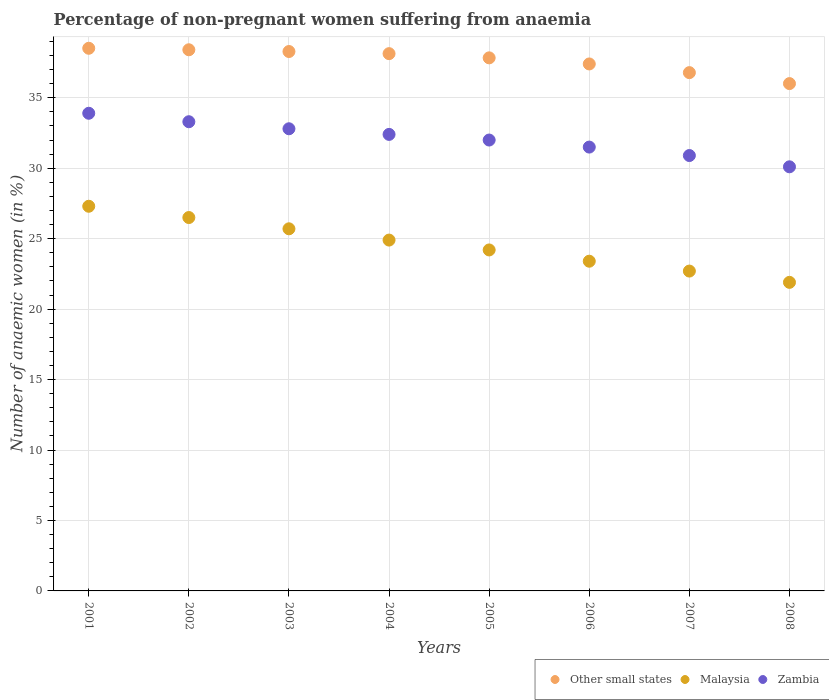What is the percentage of non-pregnant women suffering from anaemia in Other small states in 2005?
Offer a terse response. 37.83. Across all years, what is the maximum percentage of non-pregnant women suffering from anaemia in Other small states?
Ensure brevity in your answer.  38.51. Across all years, what is the minimum percentage of non-pregnant women suffering from anaemia in Zambia?
Offer a terse response. 30.1. In which year was the percentage of non-pregnant women suffering from anaemia in Other small states maximum?
Ensure brevity in your answer.  2001. What is the total percentage of non-pregnant women suffering from anaemia in Malaysia in the graph?
Ensure brevity in your answer.  196.6. What is the difference between the percentage of non-pregnant women suffering from anaemia in Malaysia in 2003 and that in 2005?
Offer a terse response. 1.5. What is the difference between the percentage of non-pregnant women suffering from anaemia in Malaysia in 2004 and the percentage of non-pregnant women suffering from anaemia in Zambia in 2002?
Your answer should be very brief. -8.4. What is the average percentage of non-pregnant women suffering from anaemia in Other small states per year?
Provide a succinct answer. 37.67. In the year 2003, what is the difference between the percentage of non-pregnant women suffering from anaemia in Other small states and percentage of non-pregnant women suffering from anaemia in Zambia?
Your answer should be compact. 5.48. In how many years, is the percentage of non-pregnant women suffering from anaemia in Other small states greater than 21 %?
Provide a succinct answer. 8. What is the ratio of the percentage of non-pregnant women suffering from anaemia in Zambia in 2003 to that in 2006?
Your answer should be very brief. 1.04. Is the percentage of non-pregnant women suffering from anaemia in Other small states in 2001 less than that in 2005?
Keep it short and to the point. No. Is the difference between the percentage of non-pregnant women suffering from anaemia in Other small states in 2007 and 2008 greater than the difference between the percentage of non-pregnant women suffering from anaemia in Zambia in 2007 and 2008?
Keep it short and to the point. No. What is the difference between the highest and the second highest percentage of non-pregnant women suffering from anaemia in Other small states?
Offer a terse response. 0.11. What is the difference between the highest and the lowest percentage of non-pregnant women suffering from anaemia in Zambia?
Provide a succinct answer. 3.8. Is the percentage of non-pregnant women suffering from anaemia in Other small states strictly less than the percentage of non-pregnant women suffering from anaemia in Zambia over the years?
Make the answer very short. No. How many legend labels are there?
Make the answer very short. 3. What is the title of the graph?
Keep it short and to the point. Percentage of non-pregnant women suffering from anaemia. Does "Korea (Republic)" appear as one of the legend labels in the graph?
Keep it short and to the point. No. What is the label or title of the Y-axis?
Offer a very short reply. Number of anaemic women (in %). What is the Number of anaemic women (in %) of Other small states in 2001?
Offer a terse response. 38.51. What is the Number of anaemic women (in %) of Malaysia in 2001?
Give a very brief answer. 27.3. What is the Number of anaemic women (in %) in Zambia in 2001?
Ensure brevity in your answer.  33.9. What is the Number of anaemic women (in %) of Other small states in 2002?
Provide a succinct answer. 38.41. What is the Number of anaemic women (in %) of Zambia in 2002?
Your response must be concise. 33.3. What is the Number of anaemic women (in %) of Other small states in 2003?
Offer a terse response. 38.28. What is the Number of anaemic women (in %) of Malaysia in 2003?
Keep it short and to the point. 25.7. What is the Number of anaemic women (in %) in Zambia in 2003?
Your response must be concise. 32.8. What is the Number of anaemic women (in %) of Other small states in 2004?
Your answer should be compact. 38.13. What is the Number of anaemic women (in %) of Malaysia in 2004?
Give a very brief answer. 24.9. What is the Number of anaemic women (in %) of Zambia in 2004?
Provide a short and direct response. 32.4. What is the Number of anaemic women (in %) in Other small states in 2005?
Keep it short and to the point. 37.83. What is the Number of anaemic women (in %) in Malaysia in 2005?
Your response must be concise. 24.2. What is the Number of anaemic women (in %) in Zambia in 2005?
Offer a terse response. 32. What is the Number of anaemic women (in %) of Other small states in 2006?
Your answer should be compact. 37.4. What is the Number of anaemic women (in %) of Malaysia in 2006?
Make the answer very short. 23.4. What is the Number of anaemic women (in %) in Zambia in 2006?
Provide a short and direct response. 31.5. What is the Number of anaemic women (in %) in Other small states in 2007?
Make the answer very short. 36.78. What is the Number of anaemic women (in %) in Malaysia in 2007?
Provide a short and direct response. 22.7. What is the Number of anaemic women (in %) in Zambia in 2007?
Provide a succinct answer. 30.9. What is the Number of anaemic women (in %) of Other small states in 2008?
Make the answer very short. 36.01. What is the Number of anaemic women (in %) of Malaysia in 2008?
Offer a terse response. 21.9. What is the Number of anaemic women (in %) in Zambia in 2008?
Make the answer very short. 30.1. Across all years, what is the maximum Number of anaemic women (in %) in Other small states?
Offer a terse response. 38.51. Across all years, what is the maximum Number of anaemic women (in %) of Malaysia?
Offer a very short reply. 27.3. Across all years, what is the maximum Number of anaemic women (in %) of Zambia?
Your response must be concise. 33.9. Across all years, what is the minimum Number of anaemic women (in %) in Other small states?
Your response must be concise. 36.01. Across all years, what is the minimum Number of anaemic women (in %) in Malaysia?
Offer a very short reply. 21.9. Across all years, what is the minimum Number of anaemic women (in %) of Zambia?
Provide a short and direct response. 30.1. What is the total Number of anaemic women (in %) in Other small states in the graph?
Make the answer very short. 301.36. What is the total Number of anaemic women (in %) in Malaysia in the graph?
Keep it short and to the point. 196.6. What is the total Number of anaemic women (in %) in Zambia in the graph?
Ensure brevity in your answer.  256.9. What is the difference between the Number of anaemic women (in %) in Other small states in 2001 and that in 2002?
Make the answer very short. 0.11. What is the difference between the Number of anaemic women (in %) in Other small states in 2001 and that in 2003?
Your answer should be very brief. 0.23. What is the difference between the Number of anaemic women (in %) of Malaysia in 2001 and that in 2003?
Your response must be concise. 1.6. What is the difference between the Number of anaemic women (in %) in Other small states in 2001 and that in 2004?
Provide a succinct answer. 0.38. What is the difference between the Number of anaemic women (in %) in Malaysia in 2001 and that in 2004?
Provide a short and direct response. 2.4. What is the difference between the Number of anaemic women (in %) in Zambia in 2001 and that in 2004?
Keep it short and to the point. 1.5. What is the difference between the Number of anaemic women (in %) of Other small states in 2001 and that in 2005?
Offer a terse response. 0.68. What is the difference between the Number of anaemic women (in %) of Malaysia in 2001 and that in 2005?
Offer a very short reply. 3.1. What is the difference between the Number of anaemic women (in %) in Other small states in 2001 and that in 2006?
Ensure brevity in your answer.  1.11. What is the difference between the Number of anaemic women (in %) of Zambia in 2001 and that in 2006?
Provide a succinct answer. 2.4. What is the difference between the Number of anaemic women (in %) of Other small states in 2001 and that in 2007?
Offer a terse response. 1.73. What is the difference between the Number of anaemic women (in %) of Malaysia in 2001 and that in 2007?
Offer a terse response. 4.6. What is the difference between the Number of anaemic women (in %) of Zambia in 2001 and that in 2007?
Your answer should be very brief. 3. What is the difference between the Number of anaemic women (in %) of Other small states in 2001 and that in 2008?
Make the answer very short. 2.51. What is the difference between the Number of anaemic women (in %) in Malaysia in 2001 and that in 2008?
Make the answer very short. 5.4. What is the difference between the Number of anaemic women (in %) in Zambia in 2001 and that in 2008?
Offer a terse response. 3.8. What is the difference between the Number of anaemic women (in %) in Other small states in 2002 and that in 2003?
Make the answer very short. 0.12. What is the difference between the Number of anaemic women (in %) of Other small states in 2002 and that in 2004?
Your answer should be very brief. 0.28. What is the difference between the Number of anaemic women (in %) of Malaysia in 2002 and that in 2004?
Give a very brief answer. 1.6. What is the difference between the Number of anaemic women (in %) in Other small states in 2002 and that in 2005?
Provide a short and direct response. 0.57. What is the difference between the Number of anaemic women (in %) in Zambia in 2002 and that in 2005?
Give a very brief answer. 1.3. What is the difference between the Number of anaemic women (in %) in Other small states in 2002 and that in 2006?
Provide a succinct answer. 1.01. What is the difference between the Number of anaemic women (in %) in Zambia in 2002 and that in 2006?
Offer a very short reply. 1.8. What is the difference between the Number of anaemic women (in %) of Other small states in 2002 and that in 2007?
Provide a short and direct response. 1.62. What is the difference between the Number of anaemic women (in %) of Zambia in 2002 and that in 2007?
Provide a short and direct response. 2.4. What is the difference between the Number of anaemic women (in %) of Other small states in 2002 and that in 2008?
Offer a terse response. 2.4. What is the difference between the Number of anaemic women (in %) of Malaysia in 2002 and that in 2008?
Offer a terse response. 4.6. What is the difference between the Number of anaemic women (in %) of Other small states in 2003 and that in 2004?
Make the answer very short. 0.15. What is the difference between the Number of anaemic women (in %) of Malaysia in 2003 and that in 2004?
Your response must be concise. 0.8. What is the difference between the Number of anaemic women (in %) of Other small states in 2003 and that in 2005?
Your response must be concise. 0.45. What is the difference between the Number of anaemic women (in %) of Zambia in 2003 and that in 2005?
Your answer should be compact. 0.8. What is the difference between the Number of anaemic women (in %) in Other small states in 2003 and that in 2006?
Keep it short and to the point. 0.88. What is the difference between the Number of anaemic women (in %) in Zambia in 2003 and that in 2006?
Make the answer very short. 1.3. What is the difference between the Number of anaemic women (in %) of Other small states in 2003 and that in 2007?
Your answer should be very brief. 1.5. What is the difference between the Number of anaemic women (in %) of Malaysia in 2003 and that in 2007?
Give a very brief answer. 3. What is the difference between the Number of anaemic women (in %) of Other small states in 2003 and that in 2008?
Give a very brief answer. 2.28. What is the difference between the Number of anaemic women (in %) in Zambia in 2003 and that in 2008?
Provide a short and direct response. 2.7. What is the difference between the Number of anaemic women (in %) in Other small states in 2004 and that in 2005?
Give a very brief answer. 0.3. What is the difference between the Number of anaemic women (in %) in Zambia in 2004 and that in 2005?
Ensure brevity in your answer.  0.4. What is the difference between the Number of anaemic women (in %) of Other small states in 2004 and that in 2006?
Your response must be concise. 0.73. What is the difference between the Number of anaemic women (in %) of Malaysia in 2004 and that in 2006?
Offer a terse response. 1.5. What is the difference between the Number of anaemic women (in %) of Other small states in 2004 and that in 2007?
Your response must be concise. 1.35. What is the difference between the Number of anaemic women (in %) in Malaysia in 2004 and that in 2007?
Provide a succinct answer. 2.2. What is the difference between the Number of anaemic women (in %) in Zambia in 2004 and that in 2007?
Your answer should be very brief. 1.5. What is the difference between the Number of anaemic women (in %) in Other small states in 2004 and that in 2008?
Provide a succinct answer. 2.13. What is the difference between the Number of anaemic women (in %) of Malaysia in 2004 and that in 2008?
Give a very brief answer. 3. What is the difference between the Number of anaemic women (in %) in Zambia in 2004 and that in 2008?
Your response must be concise. 2.3. What is the difference between the Number of anaemic women (in %) of Other small states in 2005 and that in 2006?
Make the answer very short. 0.43. What is the difference between the Number of anaemic women (in %) in Malaysia in 2005 and that in 2006?
Offer a very short reply. 0.8. What is the difference between the Number of anaemic women (in %) of Other small states in 2005 and that in 2007?
Provide a succinct answer. 1.05. What is the difference between the Number of anaemic women (in %) in Zambia in 2005 and that in 2007?
Ensure brevity in your answer.  1.1. What is the difference between the Number of anaemic women (in %) of Other small states in 2005 and that in 2008?
Offer a very short reply. 1.83. What is the difference between the Number of anaemic women (in %) in Other small states in 2006 and that in 2007?
Offer a terse response. 0.62. What is the difference between the Number of anaemic women (in %) of Malaysia in 2006 and that in 2007?
Make the answer very short. 0.7. What is the difference between the Number of anaemic women (in %) of Other small states in 2006 and that in 2008?
Keep it short and to the point. 1.39. What is the difference between the Number of anaemic women (in %) in Other small states in 2007 and that in 2008?
Provide a short and direct response. 0.78. What is the difference between the Number of anaemic women (in %) of Other small states in 2001 and the Number of anaemic women (in %) of Malaysia in 2002?
Your answer should be compact. 12.01. What is the difference between the Number of anaemic women (in %) of Other small states in 2001 and the Number of anaemic women (in %) of Zambia in 2002?
Make the answer very short. 5.21. What is the difference between the Number of anaemic women (in %) of Malaysia in 2001 and the Number of anaemic women (in %) of Zambia in 2002?
Provide a succinct answer. -6. What is the difference between the Number of anaemic women (in %) of Other small states in 2001 and the Number of anaemic women (in %) of Malaysia in 2003?
Give a very brief answer. 12.81. What is the difference between the Number of anaemic women (in %) of Other small states in 2001 and the Number of anaemic women (in %) of Zambia in 2003?
Your answer should be compact. 5.71. What is the difference between the Number of anaemic women (in %) of Malaysia in 2001 and the Number of anaemic women (in %) of Zambia in 2003?
Your answer should be compact. -5.5. What is the difference between the Number of anaemic women (in %) in Other small states in 2001 and the Number of anaemic women (in %) in Malaysia in 2004?
Make the answer very short. 13.61. What is the difference between the Number of anaemic women (in %) of Other small states in 2001 and the Number of anaemic women (in %) of Zambia in 2004?
Your response must be concise. 6.11. What is the difference between the Number of anaemic women (in %) in Malaysia in 2001 and the Number of anaemic women (in %) in Zambia in 2004?
Provide a short and direct response. -5.1. What is the difference between the Number of anaemic women (in %) in Other small states in 2001 and the Number of anaemic women (in %) in Malaysia in 2005?
Offer a terse response. 14.31. What is the difference between the Number of anaemic women (in %) in Other small states in 2001 and the Number of anaemic women (in %) in Zambia in 2005?
Provide a short and direct response. 6.51. What is the difference between the Number of anaemic women (in %) of Malaysia in 2001 and the Number of anaemic women (in %) of Zambia in 2005?
Make the answer very short. -4.7. What is the difference between the Number of anaemic women (in %) in Other small states in 2001 and the Number of anaemic women (in %) in Malaysia in 2006?
Provide a short and direct response. 15.11. What is the difference between the Number of anaemic women (in %) of Other small states in 2001 and the Number of anaemic women (in %) of Zambia in 2006?
Make the answer very short. 7.01. What is the difference between the Number of anaemic women (in %) of Other small states in 2001 and the Number of anaemic women (in %) of Malaysia in 2007?
Make the answer very short. 15.81. What is the difference between the Number of anaemic women (in %) of Other small states in 2001 and the Number of anaemic women (in %) of Zambia in 2007?
Make the answer very short. 7.61. What is the difference between the Number of anaemic women (in %) in Other small states in 2001 and the Number of anaemic women (in %) in Malaysia in 2008?
Your answer should be compact. 16.61. What is the difference between the Number of anaemic women (in %) in Other small states in 2001 and the Number of anaemic women (in %) in Zambia in 2008?
Provide a succinct answer. 8.41. What is the difference between the Number of anaemic women (in %) of Other small states in 2002 and the Number of anaemic women (in %) of Malaysia in 2003?
Give a very brief answer. 12.71. What is the difference between the Number of anaemic women (in %) in Other small states in 2002 and the Number of anaemic women (in %) in Zambia in 2003?
Your answer should be compact. 5.61. What is the difference between the Number of anaemic women (in %) in Other small states in 2002 and the Number of anaemic women (in %) in Malaysia in 2004?
Keep it short and to the point. 13.51. What is the difference between the Number of anaemic women (in %) in Other small states in 2002 and the Number of anaemic women (in %) in Zambia in 2004?
Ensure brevity in your answer.  6.01. What is the difference between the Number of anaemic women (in %) in Malaysia in 2002 and the Number of anaemic women (in %) in Zambia in 2004?
Make the answer very short. -5.9. What is the difference between the Number of anaemic women (in %) of Other small states in 2002 and the Number of anaemic women (in %) of Malaysia in 2005?
Your response must be concise. 14.21. What is the difference between the Number of anaemic women (in %) in Other small states in 2002 and the Number of anaemic women (in %) in Zambia in 2005?
Keep it short and to the point. 6.41. What is the difference between the Number of anaemic women (in %) in Other small states in 2002 and the Number of anaemic women (in %) in Malaysia in 2006?
Give a very brief answer. 15.01. What is the difference between the Number of anaemic women (in %) of Other small states in 2002 and the Number of anaemic women (in %) of Zambia in 2006?
Offer a terse response. 6.91. What is the difference between the Number of anaemic women (in %) in Malaysia in 2002 and the Number of anaemic women (in %) in Zambia in 2006?
Ensure brevity in your answer.  -5. What is the difference between the Number of anaemic women (in %) of Other small states in 2002 and the Number of anaemic women (in %) of Malaysia in 2007?
Provide a succinct answer. 15.71. What is the difference between the Number of anaemic women (in %) of Other small states in 2002 and the Number of anaemic women (in %) of Zambia in 2007?
Your response must be concise. 7.51. What is the difference between the Number of anaemic women (in %) in Other small states in 2002 and the Number of anaemic women (in %) in Malaysia in 2008?
Provide a short and direct response. 16.51. What is the difference between the Number of anaemic women (in %) of Other small states in 2002 and the Number of anaemic women (in %) of Zambia in 2008?
Your answer should be very brief. 8.31. What is the difference between the Number of anaemic women (in %) of Malaysia in 2002 and the Number of anaemic women (in %) of Zambia in 2008?
Ensure brevity in your answer.  -3.6. What is the difference between the Number of anaemic women (in %) in Other small states in 2003 and the Number of anaemic women (in %) in Malaysia in 2004?
Your answer should be very brief. 13.38. What is the difference between the Number of anaemic women (in %) of Other small states in 2003 and the Number of anaemic women (in %) of Zambia in 2004?
Your response must be concise. 5.88. What is the difference between the Number of anaemic women (in %) in Other small states in 2003 and the Number of anaemic women (in %) in Malaysia in 2005?
Your answer should be compact. 14.08. What is the difference between the Number of anaemic women (in %) of Other small states in 2003 and the Number of anaemic women (in %) of Zambia in 2005?
Provide a short and direct response. 6.28. What is the difference between the Number of anaemic women (in %) in Malaysia in 2003 and the Number of anaemic women (in %) in Zambia in 2005?
Provide a short and direct response. -6.3. What is the difference between the Number of anaemic women (in %) in Other small states in 2003 and the Number of anaemic women (in %) in Malaysia in 2006?
Ensure brevity in your answer.  14.88. What is the difference between the Number of anaemic women (in %) in Other small states in 2003 and the Number of anaemic women (in %) in Zambia in 2006?
Ensure brevity in your answer.  6.78. What is the difference between the Number of anaemic women (in %) in Other small states in 2003 and the Number of anaemic women (in %) in Malaysia in 2007?
Provide a short and direct response. 15.58. What is the difference between the Number of anaemic women (in %) of Other small states in 2003 and the Number of anaemic women (in %) of Zambia in 2007?
Ensure brevity in your answer.  7.38. What is the difference between the Number of anaemic women (in %) in Malaysia in 2003 and the Number of anaemic women (in %) in Zambia in 2007?
Keep it short and to the point. -5.2. What is the difference between the Number of anaemic women (in %) in Other small states in 2003 and the Number of anaemic women (in %) in Malaysia in 2008?
Your response must be concise. 16.38. What is the difference between the Number of anaemic women (in %) of Other small states in 2003 and the Number of anaemic women (in %) of Zambia in 2008?
Give a very brief answer. 8.18. What is the difference between the Number of anaemic women (in %) in Malaysia in 2003 and the Number of anaemic women (in %) in Zambia in 2008?
Make the answer very short. -4.4. What is the difference between the Number of anaemic women (in %) of Other small states in 2004 and the Number of anaemic women (in %) of Malaysia in 2005?
Your answer should be compact. 13.93. What is the difference between the Number of anaemic women (in %) of Other small states in 2004 and the Number of anaemic women (in %) of Zambia in 2005?
Provide a succinct answer. 6.13. What is the difference between the Number of anaemic women (in %) in Malaysia in 2004 and the Number of anaemic women (in %) in Zambia in 2005?
Offer a terse response. -7.1. What is the difference between the Number of anaemic women (in %) in Other small states in 2004 and the Number of anaemic women (in %) in Malaysia in 2006?
Offer a very short reply. 14.73. What is the difference between the Number of anaemic women (in %) of Other small states in 2004 and the Number of anaemic women (in %) of Zambia in 2006?
Your response must be concise. 6.63. What is the difference between the Number of anaemic women (in %) in Malaysia in 2004 and the Number of anaemic women (in %) in Zambia in 2006?
Make the answer very short. -6.6. What is the difference between the Number of anaemic women (in %) of Other small states in 2004 and the Number of anaemic women (in %) of Malaysia in 2007?
Your response must be concise. 15.43. What is the difference between the Number of anaemic women (in %) in Other small states in 2004 and the Number of anaemic women (in %) in Zambia in 2007?
Your answer should be very brief. 7.23. What is the difference between the Number of anaemic women (in %) in Other small states in 2004 and the Number of anaemic women (in %) in Malaysia in 2008?
Keep it short and to the point. 16.23. What is the difference between the Number of anaemic women (in %) of Other small states in 2004 and the Number of anaemic women (in %) of Zambia in 2008?
Keep it short and to the point. 8.03. What is the difference between the Number of anaemic women (in %) in Other small states in 2005 and the Number of anaemic women (in %) in Malaysia in 2006?
Your answer should be compact. 14.43. What is the difference between the Number of anaemic women (in %) of Other small states in 2005 and the Number of anaemic women (in %) of Zambia in 2006?
Give a very brief answer. 6.33. What is the difference between the Number of anaemic women (in %) in Malaysia in 2005 and the Number of anaemic women (in %) in Zambia in 2006?
Ensure brevity in your answer.  -7.3. What is the difference between the Number of anaemic women (in %) of Other small states in 2005 and the Number of anaemic women (in %) of Malaysia in 2007?
Provide a succinct answer. 15.13. What is the difference between the Number of anaemic women (in %) of Other small states in 2005 and the Number of anaemic women (in %) of Zambia in 2007?
Ensure brevity in your answer.  6.93. What is the difference between the Number of anaemic women (in %) of Other small states in 2005 and the Number of anaemic women (in %) of Malaysia in 2008?
Provide a succinct answer. 15.93. What is the difference between the Number of anaemic women (in %) in Other small states in 2005 and the Number of anaemic women (in %) in Zambia in 2008?
Offer a terse response. 7.73. What is the difference between the Number of anaemic women (in %) of Malaysia in 2005 and the Number of anaemic women (in %) of Zambia in 2008?
Make the answer very short. -5.9. What is the difference between the Number of anaemic women (in %) in Other small states in 2006 and the Number of anaemic women (in %) in Malaysia in 2007?
Offer a terse response. 14.7. What is the difference between the Number of anaemic women (in %) in Other small states in 2006 and the Number of anaemic women (in %) in Zambia in 2007?
Provide a short and direct response. 6.5. What is the difference between the Number of anaemic women (in %) in Malaysia in 2006 and the Number of anaemic women (in %) in Zambia in 2007?
Your answer should be very brief. -7.5. What is the difference between the Number of anaemic women (in %) in Other small states in 2006 and the Number of anaemic women (in %) in Malaysia in 2008?
Keep it short and to the point. 15.5. What is the difference between the Number of anaemic women (in %) of Other small states in 2006 and the Number of anaemic women (in %) of Zambia in 2008?
Offer a very short reply. 7.3. What is the difference between the Number of anaemic women (in %) of Other small states in 2007 and the Number of anaemic women (in %) of Malaysia in 2008?
Give a very brief answer. 14.88. What is the difference between the Number of anaemic women (in %) of Other small states in 2007 and the Number of anaemic women (in %) of Zambia in 2008?
Offer a very short reply. 6.68. What is the difference between the Number of anaemic women (in %) of Malaysia in 2007 and the Number of anaemic women (in %) of Zambia in 2008?
Provide a short and direct response. -7.4. What is the average Number of anaemic women (in %) in Other small states per year?
Your answer should be compact. 37.67. What is the average Number of anaemic women (in %) of Malaysia per year?
Give a very brief answer. 24.57. What is the average Number of anaemic women (in %) in Zambia per year?
Offer a terse response. 32.11. In the year 2001, what is the difference between the Number of anaemic women (in %) of Other small states and Number of anaemic women (in %) of Malaysia?
Keep it short and to the point. 11.21. In the year 2001, what is the difference between the Number of anaemic women (in %) of Other small states and Number of anaemic women (in %) of Zambia?
Give a very brief answer. 4.61. In the year 2001, what is the difference between the Number of anaemic women (in %) of Malaysia and Number of anaemic women (in %) of Zambia?
Ensure brevity in your answer.  -6.6. In the year 2002, what is the difference between the Number of anaemic women (in %) of Other small states and Number of anaemic women (in %) of Malaysia?
Keep it short and to the point. 11.91. In the year 2002, what is the difference between the Number of anaemic women (in %) of Other small states and Number of anaemic women (in %) of Zambia?
Give a very brief answer. 5.11. In the year 2002, what is the difference between the Number of anaemic women (in %) of Malaysia and Number of anaemic women (in %) of Zambia?
Provide a succinct answer. -6.8. In the year 2003, what is the difference between the Number of anaemic women (in %) in Other small states and Number of anaemic women (in %) in Malaysia?
Your response must be concise. 12.58. In the year 2003, what is the difference between the Number of anaemic women (in %) in Other small states and Number of anaemic women (in %) in Zambia?
Your answer should be very brief. 5.48. In the year 2004, what is the difference between the Number of anaemic women (in %) of Other small states and Number of anaemic women (in %) of Malaysia?
Your answer should be very brief. 13.23. In the year 2004, what is the difference between the Number of anaemic women (in %) in Other small states and Number of anaemic women (in %) in Zambia?
Offer a terse response. 5.73. In the year 2005, what is the difference between the Number of anaemic women (in %) in Other small states and Number of anaemic women (in %) in Malaysia?
Offer a very short reply. 13.63. In the year 2005, what is the difference between the Number of anaemic women (in %) in Other small states and Number of anaemic women (in %) in Zambia?
Give a very brief answer. 5.83. In the year 2005, what is the difference between the Number of anaemic women (in %) in Malaysia and Number of anaemic women (in %) in Zambia?
Offer a terse response. -7.8. In the year 2006, what is the difference between the Number of anaemic women (in %) of Other small states and Number of anaemic women (in %) of Malaysia?
Your response must be concise. 14. In the year 2006, what is the difference between the Number of anaemic women (in %) of Other small states and Number of anaemic women (in %) of Zambia?
Keep it short and to the point. 5.9. In the year 2007, what is the difference between the Number of anaemic women (in %) in Other small states and Number of anaemic women (in %) in Malaysia?
Provide a succinct answer. 14.08. In the year 2007, what is the difference between the Number of anaemic women (in %) of Other small states and Number of anaemic women (in %) of Zambia?
Give a very brief answer. 5.88. In the year 2008, what is the difference between the Number of anaemic women (in %) of Other small states and Number of anaemic women (in %) of Malaysia?
Make the answer very short. 14.11. In the year 2008, what is the difference between the Number of anaemic women (in %) of Other small states and Number of anaemic women (in %) of Zambia?
Offer a very short reply. 5.91. In the year 2008, what is the difference between the Number of anaemic women (in %) in Malaysia and Number of anaemic women (in %) in Zambia?
Give a very brief answer. -8.2. What is the ratio of the Number of anaemic women (in %) in Other small states in 2001 to that in 2002?
Offer a terse response. 1. What is the ratio of the Number of anaemic women (in %) in Malaysia in 2001 to that in 2002?
Your response must be concise. 1.03. What is the ratio of the Number of anaemic women (in %) of Zambia in 2001 to that in 2002?
Offer a very short reply. 1.02. What is the ratio of the Number of anaemic women (in %) of Other small states in 2001 to that in 2003?
Offer a terse response. 1.01. What is the ratio of the Number of anaemic women (in %) of Malaysia in 2001 to that in 2003?
Your response must be concise. 1.06. What is the ratio of the Number of anaemic women (in %) in Zambia in 2001 to that in 2003?
Keep it short and to the point. 1.03. What is the ratio of the Number of anaemic women (in %) of Malaysia in 2001 to that in 2004?
Offer a terse response. 1.1. What is the ratio of the Number of anaemic women (in %) of Zambia in 2001 to that in 2004?
Offer a very short reply. 1.05. What is the ratio of the Number of anaemic women (in %) of Malaysia in 2001 to that in 2005?
Your response must be concise. 1.13. What is the ratio of the Number of anaemic women (in %) of Zambia in 2001 to that in 2005?
Offer a terse response. 1.06. What is the ratio of the Number of anaemic women (in %) in Other small states in 2001 to that in 2006?
Make the answer very short. 1.03. What is the ratio of the Number of anaemic women (in %) in Zambia in 2001 to that in 2006?
Give a very brief answer. 1.08. What is the ratio of the Number of anaemic women (in %) in Other small states in 2001 to that in 2007?
Your answer should be compact. 1.05. What is the ratio of the Number of anaemic women (in %) of Malaysia in 2001 to that in 2007?
Keep it short and to the point. 1.2. What is the ratio of the Number of anaemic women (in %) in Zambia in 2001 to that in 2007?
Your answer should be very brief. 1.1. What is the ratio of the Number of anaemic women (in %) in Other small states in 2001 to that in 2008?
Provide a succinct answer. 1.07. What is the ratio of the Number of anaemic women (in %) in Malaysia in 2001 to that in 2008?
Provide a succinct answer. 1.25. What is the ratio of the Number of anaemic women (in %) of Zambia in 2001 to that in 2008?
Offer a terse response. 1.13. What is the ratio of the Number of anaemic women (in %) of Other small states in 2002 to that in 2003?
Provide a short and direct response. 1. What is the ratio of the Number of anaemic women (in %) of Malaysia in 2002 to that in 2003?
Provide a short and direct response. 1.03. What is the ratio of the Number of anaemic women (in %) of Zambia in 2002 to that in 2003?
Provide a short and direct response. 1.02. What is the ratio of the Number of anaemic women (in %) in Malaysia in 2002 to that in 2004?
Offer a very short reply. 1.06. What is the ratio of the Number of anaemic women (in %) in Zambia in 2002 to that in 2004?
Provide a succinct answer. 1.03. What is the ratio of the Number of anaemic women (in %) in Other small states in 2002 to that in 2005?
Your answer should be very brief. 1.02. What is the ratio of the Number of anaemic women (in %) in Malaysia in 2002 to that in 2005?
Your answer should be compact. 1.09. What is the ratio of the Number of anaemic women (in %) in Zambia in 2002 to that in 2005?
Make the answer very short. 1.04. What is the ratio of the Number of anaemic women (in %) in Other small states in 2002 to that in 2006?
Make the answer very short. 1.03. What is the ratio of the Number of anaemic women (in %) of Malaysia in 2002 to that in 2006?
Keep it short and to the point. 1.13. What is the ratio of the Number of anaemic women (in %) of Zambia in 2002 to that in 2006?
Ensure brevity in your answer.  1.06. What is the ratio of the Number of anaemic women (in %) in Other small states in 2002 to that in 2007?
Offer a terse response. 1.04. What is the ratio of the Number of anaemic women (in %) in Malaysia in 2002 to that in 2007?
Your answer should be very brief. 1.17. What is the ratio of the Number of anaemic women (in %) of Zambia in 2002 to that in 2007?
Provide a short and direct response. 1.08. What is the ratio of the Number of anaemic women (in %) in Other small states in 2002 to that in 2008?
Offer a very short reply. 1.07. What is the ratio of the Number of anaemic women (in %) in Malaysia in 2002 to that in 2008?
Provide a succinct answer. 1.21. What is the ratio of the Number of anaemic women (in %) of Zambia in 2002 to that in 2008?
Give a very brief answer. 1.11. What is the ratio of the Number of anaemic women (in %) in Malaysia in 2003 to that in 2004?
Provide a short and direct response. 1.03. What is the ratio of the Number of anaemic women (in %) of Zambia in 2003 to that in 2004?
Your response must be concise. 1.01. What is the ratio of the Number of anaemic women (in %) of Other small states in 2003 to that in 2005?
Your answer should be compact. 1.01. What is the ratio of the Number of anaemic women (in %) in Malaysia in 2003 to that in 2005?
Keep it short and to the point. 1.06. What is the ratio of the Number of anaemic women (in %) of Other small states in 2003 to that in 2006?
Provide a short and direct response. 1.02. What is the ratio of the Number of anaemic women (in %) in Malaysia in 2003 to that in 2006?
Ensure brevity in your answer.  1.1. What is the ratio of the Number of anaemic women (in %) in Zambia in 2003 to that in 2006?
Keep it short and to the point. 1.04. What is the ratio of the Number of anaemic women (in %) of Other small states in 2003 to that in 2007?
Offer a terse response. 1.04. What is the ratio of the Number of anaemic women (in %) in Malaysia in 2003 to that in 2007?
Offer a terse response. 1.13. What is the ratio of the Number of anaemic women (in %) of Zambia in 2003 to that in 2007?
Your answer should be compact. 1.06. What is the ratio of the Number of anaemic women (in %) of Other small states in 2003 to that in 2008?
Give a very brief answer. 1.06. What is the ratio of the Number of anaemic women (in %) in Malaysia in 2003 to that in 2008?
Give a very brief answer. 1.17. What is the ratio of the Number of anaemic women (in %) in Zambia in 2003 to that in 2008?
Your response must be concise. 1.09. What is the ratio of the Number of anaemic women (in %) in Other small states in 2004 to that in 2005?
Offer a terse response. 1.01. What is the ratio of the Number of anaemic women (in %) in Malaysia in 2004 to that in 2005?
Provide a succinct answer. 1.03. What is the ratio of the Number of anaemic women (in %) of Zambia in 2004 to that in 2005?
Keep it short and to the point. 1.01. What is the ratio of the Number of anaemic women (in %) in Other small states in 2004 to that in 2006?
Provide a short and direct response. 1.02. What is the ratio of the Number of anaemic women (in %) of Malaysia in 2004 to that in 2006?
Offer a very short reply. 1.06. What is the ratio of the Number of anaemic women (in %) of Zambia in 2004 to that in 2006?
Give a very brief answer. 1.03. What is the ratio of the Number of anaemic women (in %) in Other small states in 2004 to that in 2007?
Keep it short and to the point. 1.04. What is the ratio of the Number of anaemic women (in %) in Malaysia in 2004 to that in 2007?
Offer a very short reply. 1.1. What is the ratio of the Number of anaemic women (in %) of Zambia in 2004 to that in 2007?
Offer a terse response. 1.05. What is the ratio of the Number of anaemic women (in %) in Other small states in 2004 to that in 2008?
Your answer should be compact. 1.06. What is the ratio of the Number of anaemic women (in %) of Malaysia in 2004 to that in 2008?
Give a very brief answer. 1.14. What is the ratio of the Number of anaemic women (in %) in Zambia in 2004 to that in 2008?
Provide a succinct answer. 1.08. What is the ratio of the Number of anaemic women (in %) of Other small states in 2005 to that in 2006?
Provide a succinct answer. 1.01. What is the ratio of the Number of anaemic women (in %) of Malaysia in 2005 to that in 2006?
Offer a very short reply. 1.03. What is the ratio of the Number of anaemic women (in %) in Zambia in 2005 to that in 2006?
Ensure brevity in your answer.  1.02. What is the ratio of the Number of anaemic women (in %) of Other small states in 2005 to that in 2007?
Provide a short and direct response. 1.03. What is the ratio of the Number of anaemic women (in %) of Malaysia in 2005 to that in 2007?
Your answer should be compact. 1.07. What is the ratio of the Number of anaemic women (in %) in Zambia in 2005 to that in 2007?
Make the answer very short. 1.04. What is the ratio of the Number of anaemic women (in %) in Other small states in 2005 to that in 2008?
Keep it short and to the point. 1.05. What is the ratio of the Number of anaemic women (in %) in Malaysia in 2005 to that in 2008?
Ensure brevity in your answer.  1.1. What is the ratio of the Number of anaemic women (in %) in Zambia in 2005 to that in 2008?
Provide a succinct answer. 1.06. What is the ratio of the Number of anaemic women (in %) of Other small states in 2006 to that in 2007?
Make the answer very short. 1.02. What is the ratio of the Number of anaemic women (in %) in Malaysia in 2006 to that in 2007?
Offer a terse response. 1.03. What is the ratio of the Number of anaemic women (in %) of Zambia in 2006 to that in 2007?
Offer a very short reply. 1.02. What is the ratio of the Number of anaemic women (in %) of Other small states in 2006 to that in 2008?
Your answer should be very brief. 1.04. What is the ratio of the Number of anaemic women (in %) of Malaysia in 2006 to that in 2008?
Your answer should be compact. 1.07. What is the ratio of the Number of anaemic women (in %) in Zambia in 2006 to that in 2008?
Ensure brevity in your answer.  1.05. What is the ratio of the Number of anaemic women (in %) in Other small states in 2007 to that in 2008?
Give a very brief answer. 1.02. What is the ratio of the Number of anaemic women (in %) in Malaysia in 2007 to that in 2008?
Offer a terse response. 1.04. What is the ratio of the Number of anaemic women (in %) of Zambia in 2007 to that in 2008?
Your answer should be compact. 1.03. What is the difference between the highest and the second highest Number of anaemic women (in %) of Other small states?
Keep it short and to the point. 0.11. What is the difference between the highest and the second highest Number of anaemic women (in %) of Zambia?
Your answer should be very brief. 0.6. What is the difference between the highest and the lowest Number of anaemic women (in %) of Other small states?
Your answer should be compact. 2.51. What is the difference between the highest and the lowest Number of anaemic women (in %) of Malaysia?
Provide a short and direct response. 5.4. What is the difference between the highest and the lowest Number of anaemic women (in %) in Zambia?
Keep it short and to the point. 3.8. 